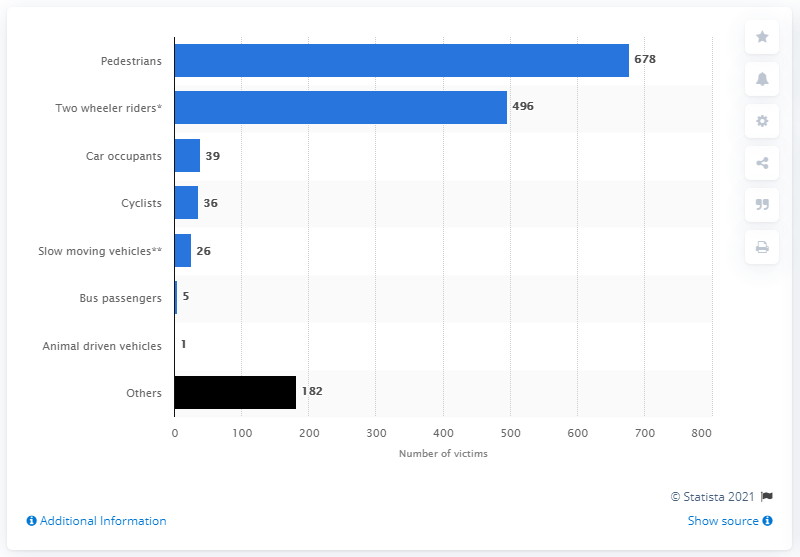Indicate a few pertinent items in this graphic. In 2019, a total of 678 pedestrians sustained fatal injuries due to road accidents in Delhi, India. 